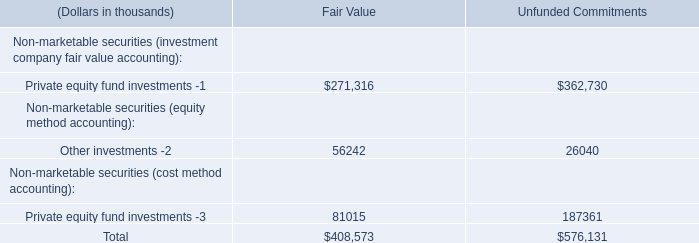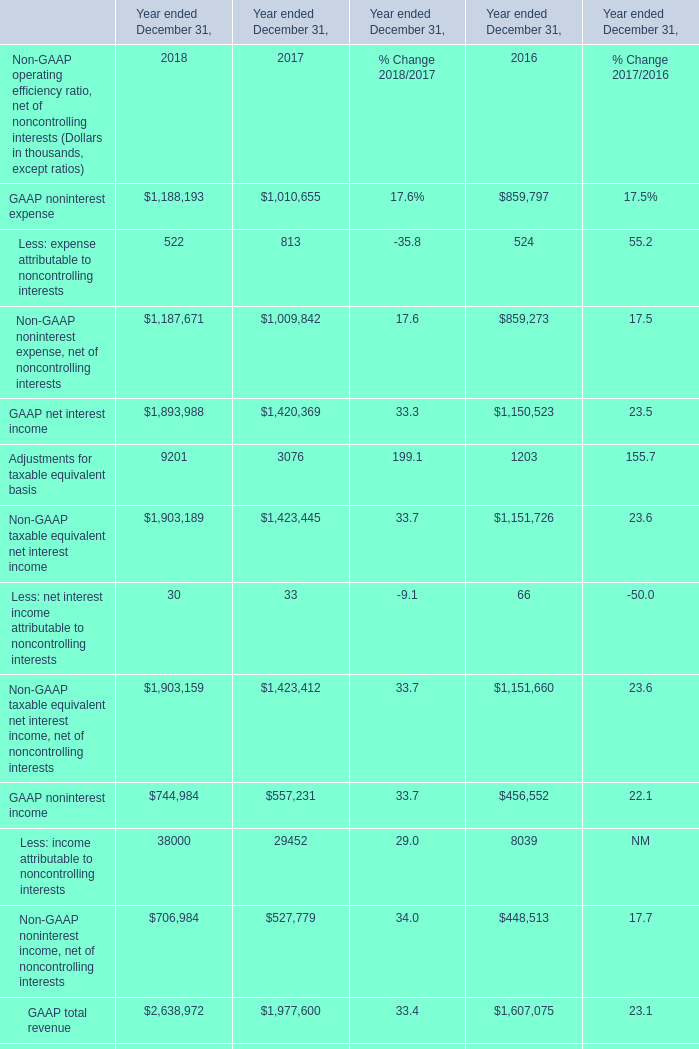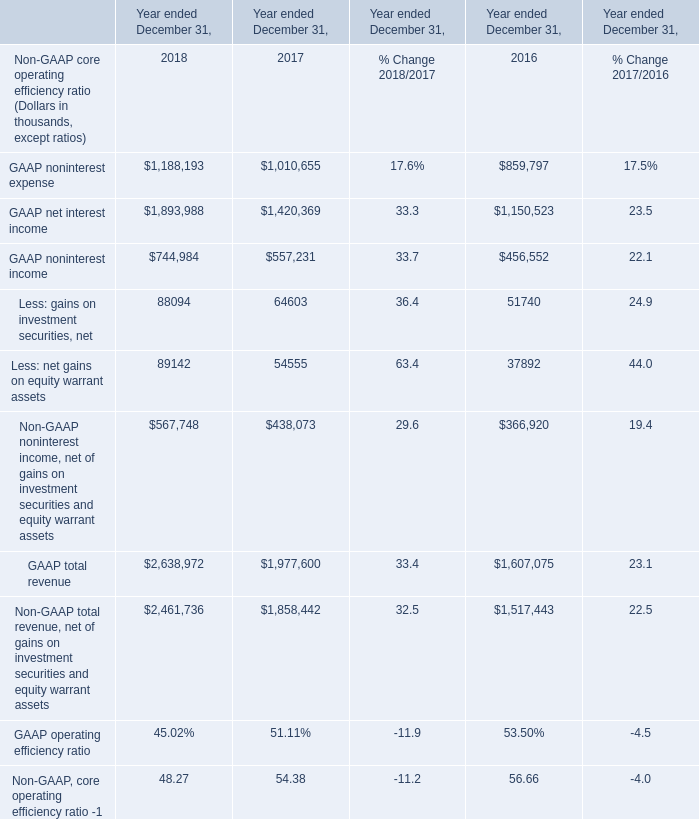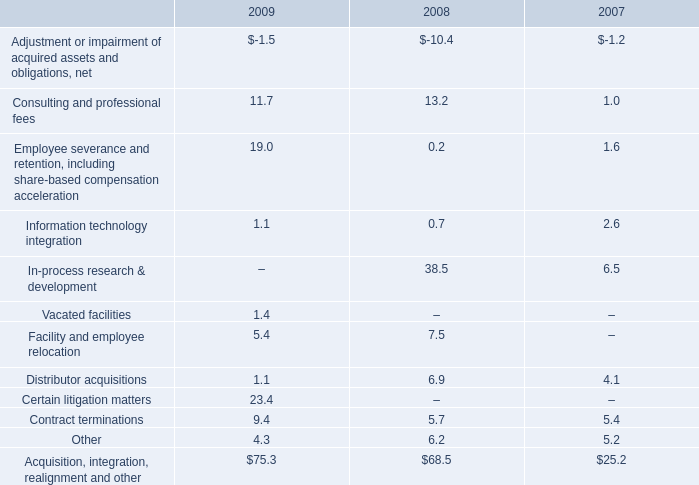In which year is Non-GAAP noninterest income, net of gains on investment securities and equity warrant assets greater than 500000? 
Answer: 2018. 